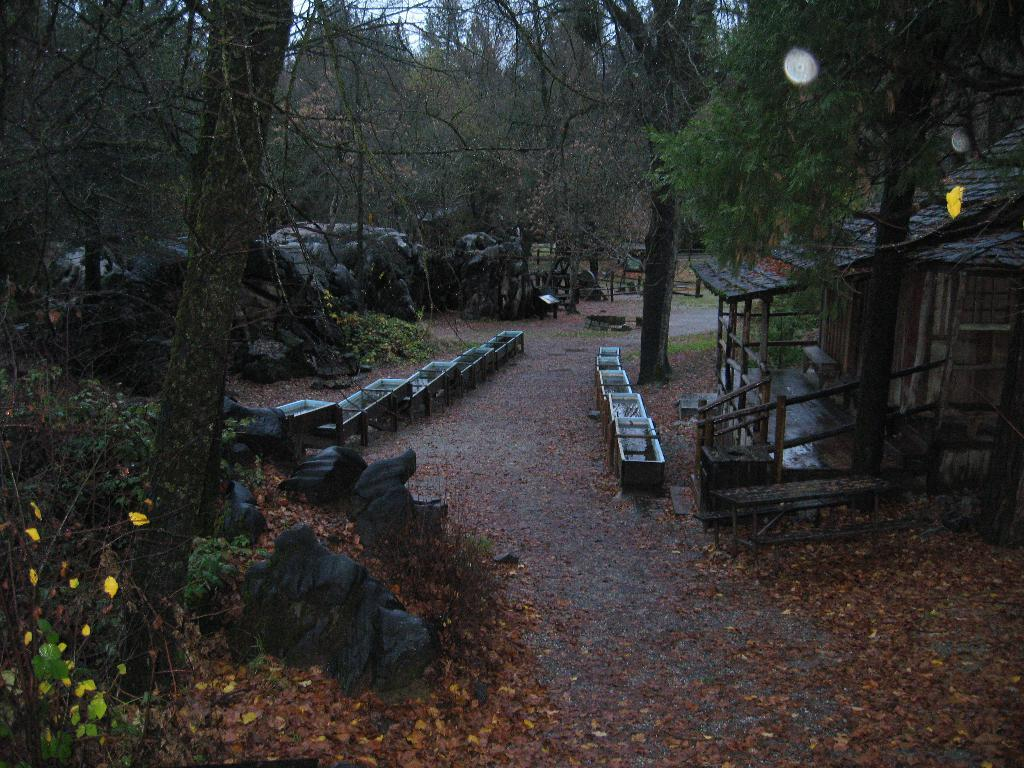What type of natural elements can be seen in the image? There are rocks, plants, and trees in the image. What type of man-made structure is present in the image? There is a house in the image. What else can be seen in the image besides the natural elements and the house? There are objects in the image. What is present on the ground in the image? Dried leaves are present on the ground in the image. What is visible in the background of the image? The sky is visible in the background of the image. What type of treatment is being administered to the plants in the image? There is no treatment being administered to the plants in the image; they are simply present in the natural environment. Are there any police officers visible in the image? No, there are no police officers present in the image. 